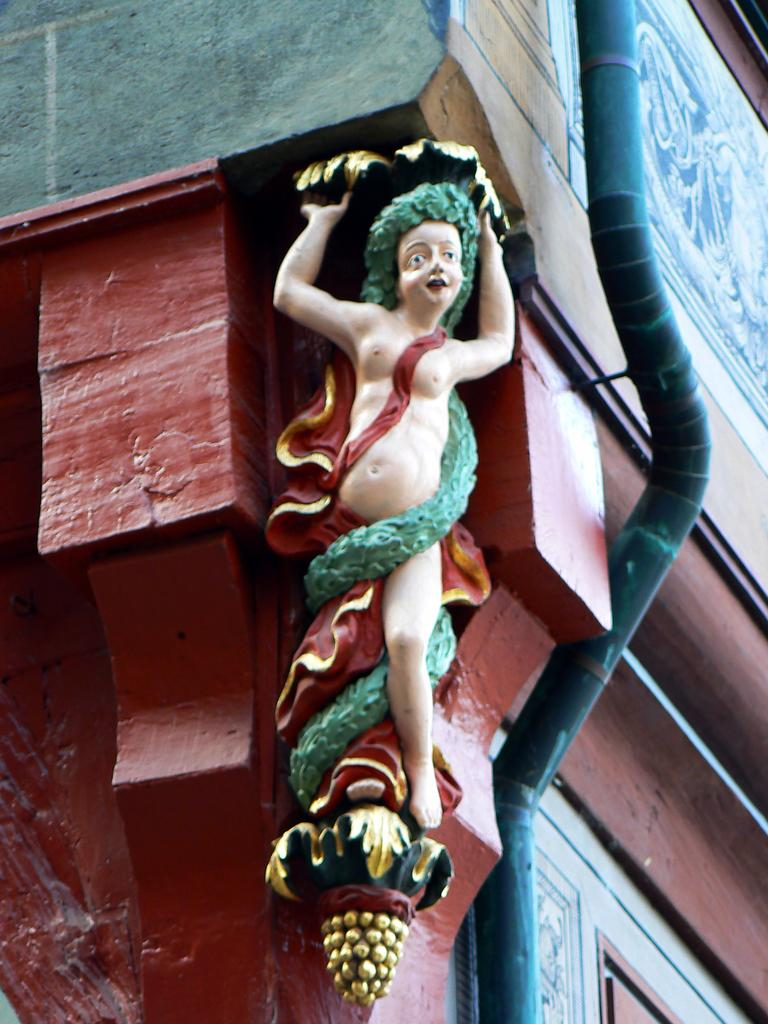What is the main subject in the center of the image? There is a statue in the center of the image. What can be seen in the background of the image? There is a building and a pipe in the background of the image. What type of stem can be seen growing from the statue in the image? There is no stem growing from the statue in the image. 